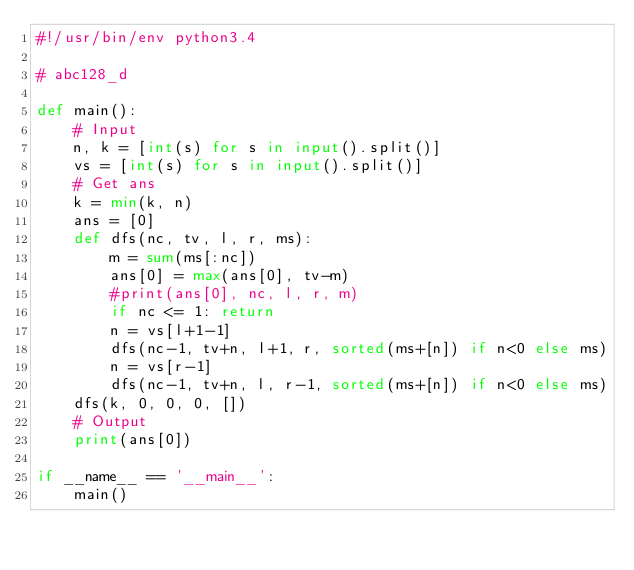<code> <loc_0><loc_0><loc_500><loc_500><_Python_>#!/usr/bin/env python3.4

# abc128_d

def main():
    # Input
    n, k = [int(s) for s in input().split()]
    vs = [int(s) for s in input().split()]
    # Get ans
    k = min(k, n)
    ans = [0]
    def dfs(nc, tv, l, r, ms):
        m = sum(ms[:nc])
        ans[0] = max(ans[0], tv-m)
        #print(ans[0], nc, l, r, m)
        if nc <= 1: return
        n = vs[l+1-1]
        dfs(nc-1, tv+n, l+1, r, sorted(ms+[n]) if n<0 else ms)
        n = vs[r-1]
        dfs(nc-1, tv+n, l, r-1, sorted(ms+[n]) if n<0 else ms)
    dfs(k, 0, 0, 0, [])
    # Output
    print(ans[0])

if __name__ == '__main__':
    main()

</code> 